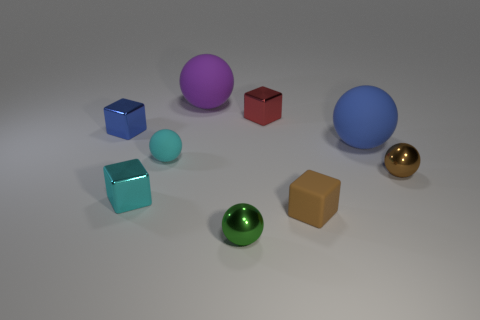Subtract all brown spheres. How many spheres are left? 4 Subtract 3 blocks. How many blocks are left? 1 Subtract all cyan blocks. How many blocks are left? 3 Add 1 cyan metallic cubes. How many objects exist? 10 Subtract all cubes. How many objects are left? 5 Subtract all purple blocks. How many purple balls are left? 1 Subtract all small blue shiny objects. Subtract all brown rubber things. How many objects are left? 7 Add 6 brown cubes. How many brown cubes are left? 7 Add 3 tiny shiny balls. How many tiny shiny balls exist? 5 Subtract 1 brown cubes. How many objects are left? 8 